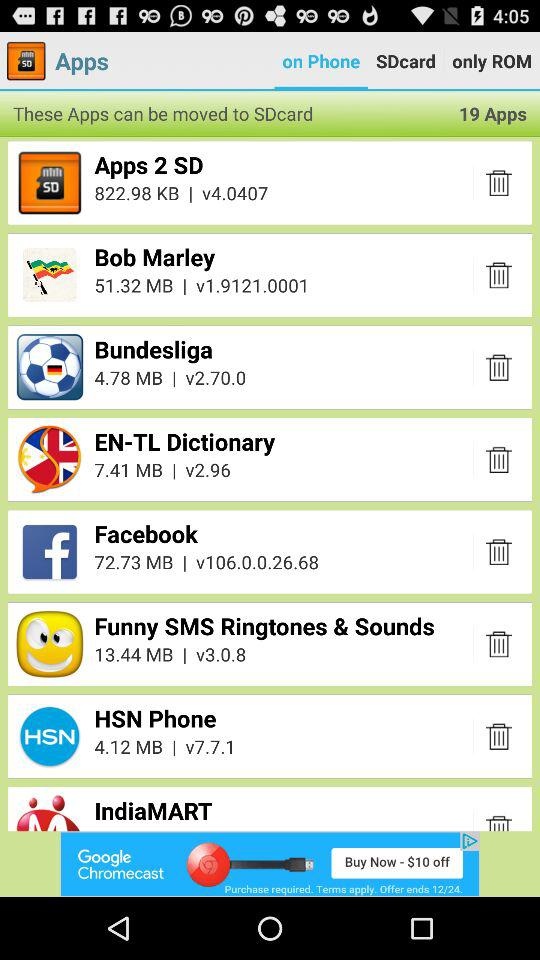How many apps can be moved to SDcard?
Answer the question using a single word or phrase. 19 